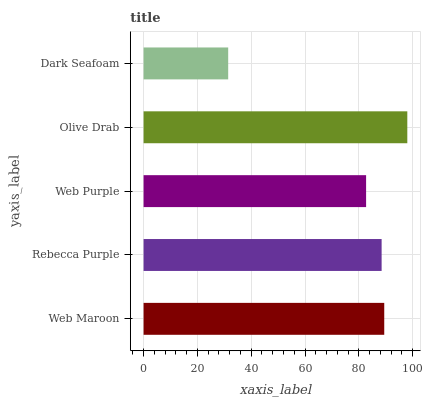Is Dark Seafoam the minimum?
Answer yes or no. Yes. Is Olive Drab the maximum?
Answer yes or no. Yes. Is Rebecca Purple the minimum?
Answer yes or no. No. Is Rebecca Purple the maximum?
Answer yes or no. No. Is Web Maroon greater than Rebecca Purple?
Answer yes or no. Yes. Is Rebecca Purple less than Web Maroon?
Answer yes or no. Yes. Is Rebecca Purple greater than Web Maroon?
Answer yes or no. No. Is Web Maroon less than Rebecca Purple?
Answer yes or no. No. Is Rebecca Purple the high median?
Answer yes or no. Yes. Is Rebecca Purple the low median?
Answer yes or no. Yes. Is Dark Seafoam the high median?
Answer yes or no. No. Is Dark Seafoam the low median?
Answer yes or no. No. 